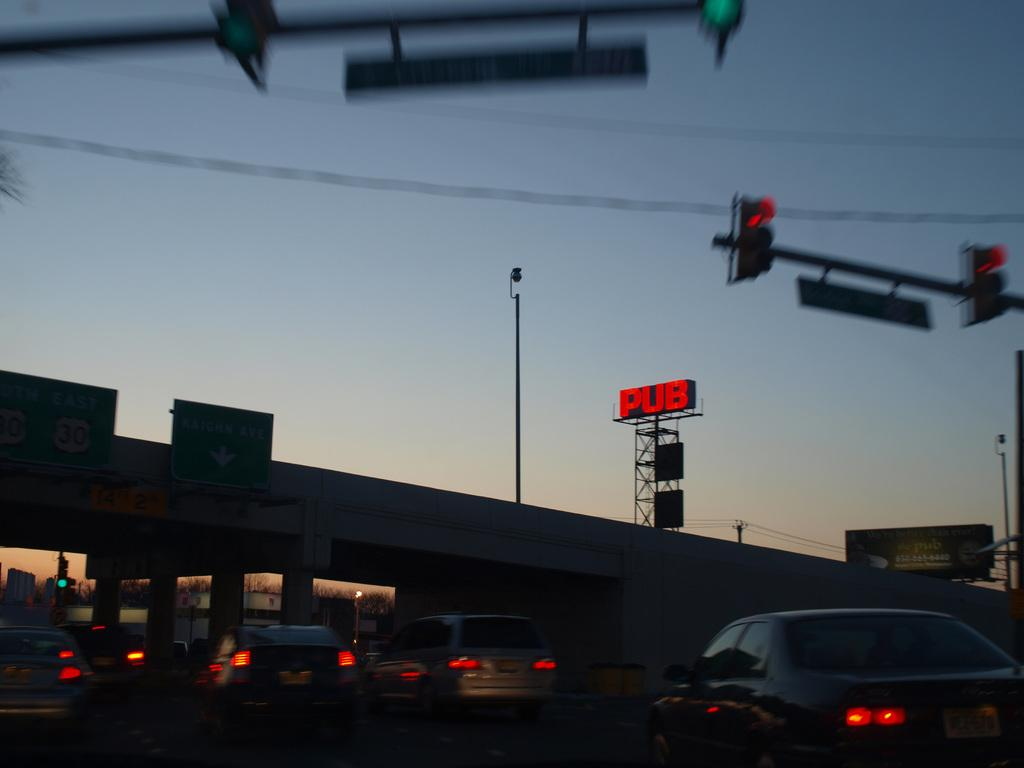<image>
Create a compact narrative representing the image presented. Vehicles passing under a bridge with a red pub sign above them. 